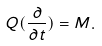Convert formula to latex. <formula><loc_0><loc_0><loc_500><loc_500>Q ( \frac { \partial } { \partial t } ) = M .</formula> 